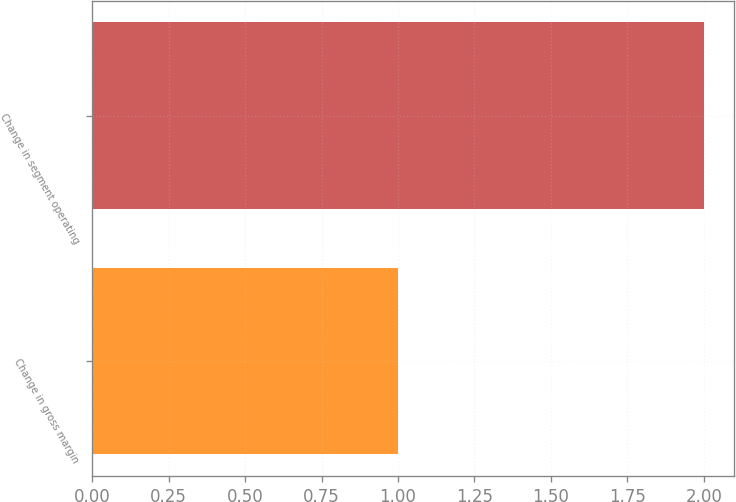<chart> <loc_0><loc_0><loc_500><loc_500><bar_chart><fcel>Change in gross margin<fcel>Change in segment operating<nl><fcel>1<fcel>2<nl></chart> 